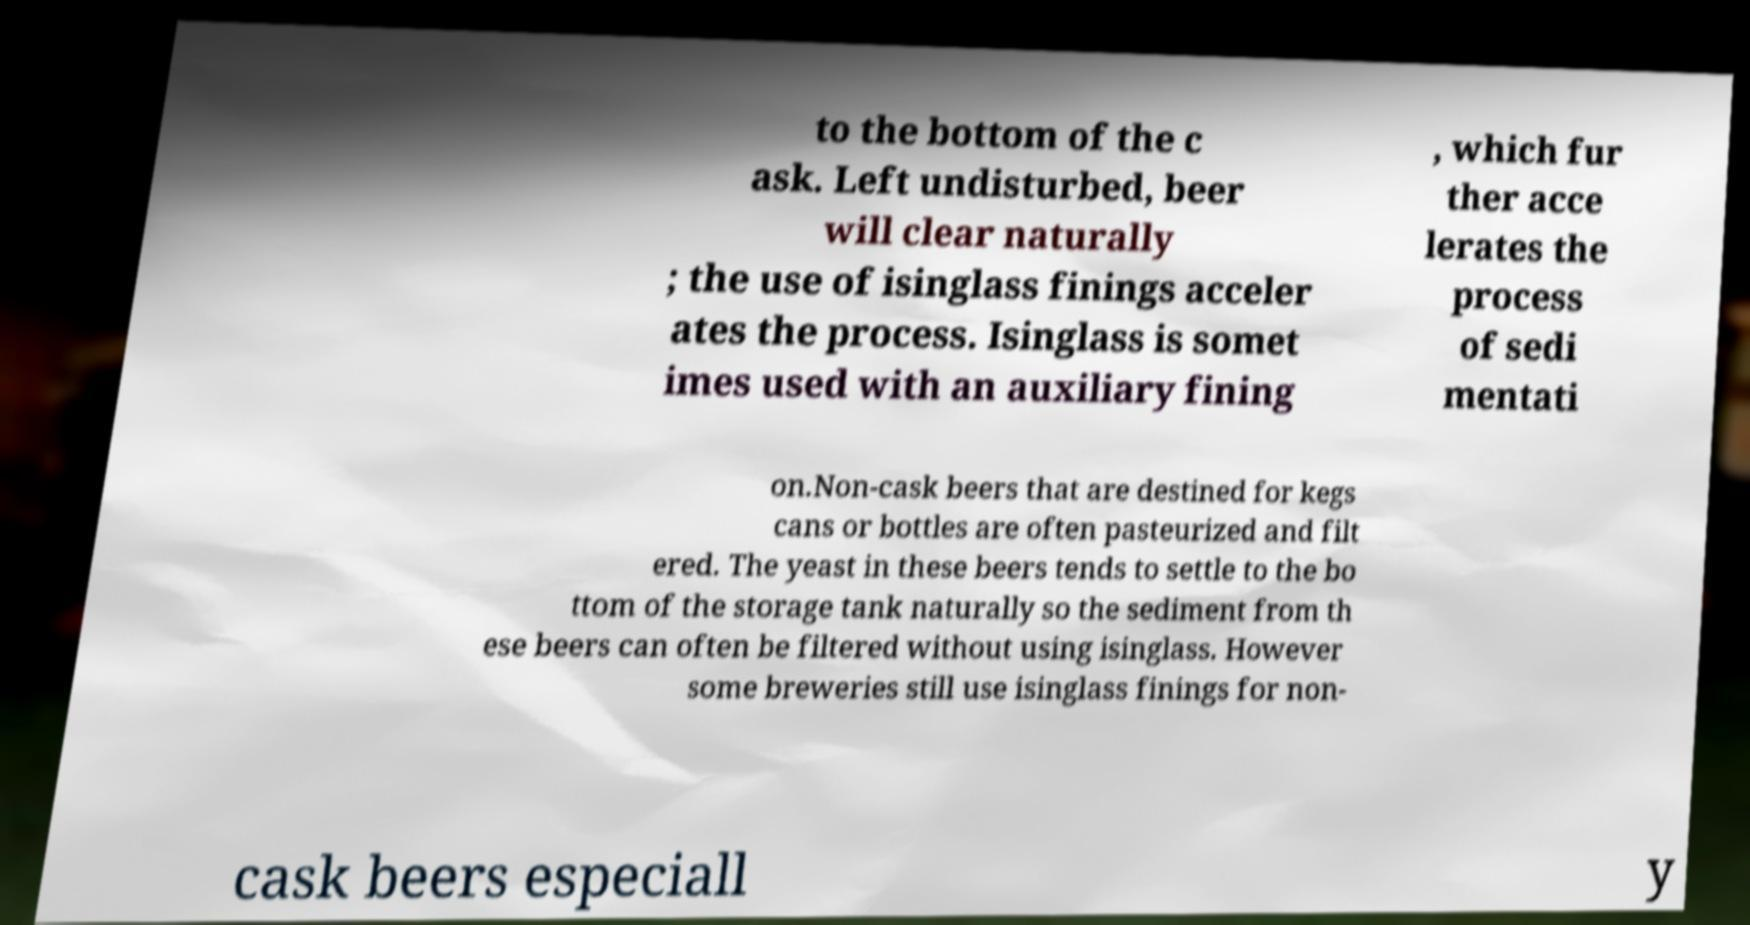Can you accurately transcribe the text from the provided image for me? to the bottom of the c ask. Left undisturbed, beer will clear naturally ; the use of isinglass finings acceler ates the process. Isinglass is somet imes used with an auxiliary fining , which fur ther acce lerates the process of sedi mentati on.Non-cask beers that are destined for kegs cans or bottles are often pasteurized and filt ered. The yeast in these beers tends to settle to the bo ttom of the storage tank naturally so the sediment from th ese beers can often be filtered without using isinglass. However some breweries still use isinglass finings for non- cask beers especiall y 